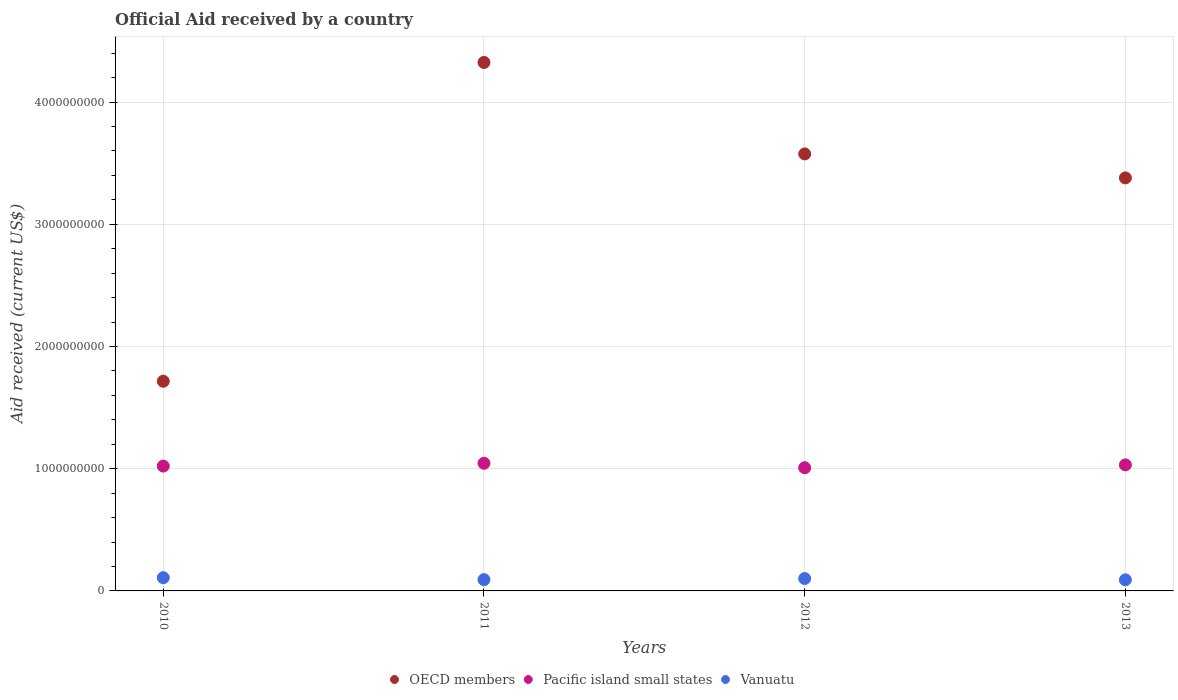What is the net official aid received in Pacific island small states in 2011?
Provide a succinct answer. 1.04e+09. Across all years, what is the maximum net official aid received in Vanuatu?
Your answer should be compact. 1.08e+08. Across all years, what is the minimum net official aid received in Pacific island small states?
Provide a succinct answer. 1.01e+09. What is the total net official aid received in OECD members in the graph?
Give a very brief answer. 1.30e+1. What is the difference between the net official aid received in Vanuatu in 2010 and that in 2013?
Make the answer very short. 1.77e+07. What is the difference between the net official aid received in Vanuatu in 2010 and the net official aid received in Pacific island small states in 2012?
Ensure brevity in your answer.  -9.00e+08. What is the average net official aid received in Vanuatu per year?
Ensure brevity in your answer.  9.81e+07. In the year 2012, what is the difference between the net official aid received in Pacific island small states and net official aid received in Vanuatu?
Keep it short and to the point. 9.06e+08. In how many years, is the net official aid received in OECD members greater than 3200000000 US$?
Ensure brevity in your answer.  3. What is the ratio of the net official aid received in Pacific island small states in 2012 to that in 2013?
Offer a very short reply. 0.98. What is the difference between the highest and the second highest net official aid received in Pacific island small states?
Provide a short and direct response. 1.30e+07. What is the difference between the highest and the lowest net official aid received in Vanuatu?
Make the answer very short. 1.77e+07. Is it the case that in every year, the sum of the net official aid received in Vanuatu and net official aid received in OECD members  is greater than the net official aid received in Pacific island small states?
Your answer should be compact. Yes. Does the net official aid received in Pacific island small states monotonically increase over the years?
Offer a very short reply. No. Is the net official aid received in OECD members strictly less than the net official aid received in Vanuatu over the years?
Provide a short and direct response. No. How many years are there in the graph?
Offer a very short reply. 4. What is the difference between two consecutive major ticks on the Y-axis?
Provide a short and direct response. 1.00e+09. Are the values on the major ticks of Y-axis written in scientific E-notation?
Keep it short and to the point. No. Does the graph contain grids?
Make the answer very short. Yes. Where does the legend appear in the graph?
Your response must be concise. Bottom center. What is the title of the graph?
Ensure brevity in your answer.  Official Aid received by a country. Does "Sub-Saharan Africa (developing only)" appear as one of the legend labels in the graph?
Make the answer very short. No. What is the label or title of the Y-axis?
Keep it short and to the point. Aid received (current US$). What is the Aid received (current US$) of OECD members in 2010?
Offer a terse response. 1.72e+09. What is the Aid received (current US$) of Pacific island small states in 2010?
Provide a short and direct response. 1.02e+09. What is the Aid received (current US$) in Vanuatu in 2010?
Your response must be concise. 1.08e+08. What is the Aid received (current US$) in OECD members in 2011?
Offer a terse response. 4.32e+09. What is the Aid received (current US$) in Pacific island small states in 2011?
Offer a very short reply. 1.04e+09. What is the Aid received (current US$) in Vanuatu in 2011?
Keep it short and to the point. 9.22e+07. What is the Aid received (current US$) in OECD members in 2012?
Make the answer very short. 3.58e+09. What is the Aid received (current US$) of Pacific island small states in 2012?
Offer a terse response. 1.01e+09. What is the Aid received (current US$) in Vanuatu in 2012?
Offer a terse response. 1.01e+08. What is the Aid received (current US$) of OECD members in 2013?
Your answer should be very brief. 3.38e+09. What is the Aid received (current US$) in Pacific island small states in 2013?
Your answer should be very brief. 1.03e+09. What is the Aid received (current US$) of Vanuatu in 2013?
Your answer should be compact. 9.06e+07. Across all years, what is the maximum Aid received (current US$) of OECD members?
Your answer should be very brief. 4.32e+09. Across all years, what is the maximum Aid received (current US$) of Pacific island small states?
Provide a succinct answer. 1.04e+09. Across all years, what is the maximum Aid received (current US$) in Vanuatu?
Your answer should be very brief. 1.08e+08. Across all years, what is the minimum Aid received (current US$) of OECD members?
Offer a very short reply. 1.72e+09. Across all years, what is the minimum Aid received (current US$) in Pacific island small states?
Your response must be concise. 1.01e+09. Across all years, what is the minimum Aid received (current US$) of Vanuatu?
Make the answer very short. 9.06e+07. What is the total Aid received (current US$) in OECD members in the graph?
Your answer should be compact. 1.30e+1. What is the total Aid received (current US$) of Pacific island small states in the graph?
Your answer should be very brief. 4.11e+09. What is the total Aid received (current US$) in Vanuatu in the graph?
Your response must be concise. 3.92e+08. What is the difference between the Aid received (current US$) in OECD members in 2010 and that in 2011?
Give a very brief answer. -2.61e+09. What is the difference between the Aid received (current US$) in Pacific island small states in 2010 and that in 2011?
Ensure brevity in your answer.  -2.31e+07. What is the difference between the Aid received (current US$) in Vanuatu in 2010 and that in 2011?
Offer a very short reply. 1.62e+07. What is the difference between the Aid received (current US$) in OECD members in 2010 and that in 2012?
Your response must be concise. -1.86e+09. What is the difference between the Aid received (current US$) of Pacific island small states in 2010 and that in 2012?
Your response must be concise. 1.36e+07. What is the difference between the Aid received (current US$) in Vanuatu in 2010 and that in 2012?
Provide a succinct answer. 6.89e+06. What is the difference between the Aid received (current US$) in OECD members in 2010 and that in 2013?
Provide a succinct answer. -1.66e+09. What is the difference between the Aid received (current US$) in Pacific island small states in 2010 and that in 2013?
Your answer should be very brief. -1.00e+07. What is the difference between the Aid received (current US$) in Vanuatu in 2010 and that in 2013?
Offer a terse response. 1.77e+07. What is the difference between the Aid received (current US$) in OECD members in 2011 and that in 2012?
Your answer should be very brief. 7.48e+08. What is the difference between the Aid received (current US$) of Pacific island small states in 2011 and that in 2012?
Ensure brevity in your answer.  3.66e+07. What is the difference between the Aid received (current US$) of Vanuatu in 2011 and that in 2012?
Your answer should be compact. -9.27e+06. What is the difference between the Aid received (current US$) of OECD members in 2011 and that in 2013?
Keep it short and to the point. 9.45e+08. What is the difference between the Aid received (current US$) in Pacific island small states in 2011 and that in 2013?
Your answer should be very brief. 1.30e+07. What is the difference between the Aid received (current US$) in Vanuatu in 2011 and that in 2013?
Make the answer very short. 1.56e+06. What is the difference between the Aid received (current US$) in OECD members in 2012 and that in 2013?
Your answer should be very brief. 1.96e+08. What is the difference between the Aid received (current US$) in Pacific island small states in 2012 and that in 2013?
Provide a short and direct response. -2.36e+07. What is the difference between the Aid received (current US$) in Vanuatu in 2012 and that in 2013?
Keep it short and to the point. 1.08e+07. What is the difference between the Aid received (current US$) in OECD members in 2010 and the Aid received (current US$) in Pacific island small states in 2011?
Provide a short and direct response. 6.71e+08. What is the difference between the Aid received (current US$) in OECD members in 2010 and the Aid received (current US$) in Vanuatu in 2011?
Your response must be concise. 1.62e+09. What is the difference between the Aid received (current US$) in Pacific island small states in 2010 and the Aid received (current US$) in Vanuatu in 2011?
Keep it short and to the point. 9.29e+08. What is the difference between the Aid received (current US$) in OECD members in 2010 and the Aid received (current US$) in Pacific island small states in 2012?
Make the answer very short. 7.08e+08. What is the difference between the Aid received (current US$) of OECD members in 2010 and the Aid received (current US$) of Vanuatu in 2012?
Provide a succinct answer. 1.61e+09. What is the difference between the Aid received (current US$) of Pacific island small states in 2010 and the Aid received (current US$) of Vanuatu in 2012?
Offer a very short reply. 9.20e+08. What is the difference between the Aid received (current US$) in OECD members in 2010 and the Aid received (current US$) in Pacific island small states in 2013?
Provide a succinct answer. 6.84e+08. What is the difference between the Aid received (current US$) of OECD members in 2010 and the Aid received (current US$) of Vanuatu in 2013?
Your answer should be very brief. 1.63e+09. What is the difference between the Aid received (current US$) of Pacific island small states in 2010 and the Aid received (current US$) of Vanuatu in 2013?
Your answer should be compact. 9.31e+08. What is the difference between the Aid received (current US$) of OECD members in 2011 and the Aid received (current US$) of Pacific island small states in 2012?
Your answer should be compact. 3.32e+09. What is the difference between the Aid received (current US$) of OECD members in 2011 and the Aid received (current US$) of Vanuatu in 2012?
Your answer should be very brief. 4.22e+09. What is the difference between the Aid received (current US$) in Pacific island small states in 2011 and the Aid received (current US$) in Vanuatu in 2012?
Your answer should be very brief. 9.43e+08. What is the difference between the Aid received (current US$) in OECD members in 2011 and the Aid received (current US$) in Pacific island small states in 2013?
Offer a terse response. 3.29e+09. What is the difference between the Aid received (current US$) in OECD members in 2011 and the Aid received (current US$) in Vanuatu in 2013?
Provide a short and direct response. 4.23e+09. What is the difference between the Aid received (current US$) in Pacific island small states in 2011 and the Aid received (current US$) in Vanuatu in 2013?
Ensure brevity in your answer.  9.54e+08. What is the difference between the Aid received (current US$) in OECD members in 2012 and the Aid received (current US$) in Pacific island small states in 2013?
Give a very brief answer. 2.54e+09. What is the difference between the Aid received (current US$) of OECD members in 2012 and the Aid received (current US$) of Vanuatu in 2013?
Give a very brief answer. 3.49e+09. What is the difference between the Aid received (current US$) of Pacific island small states in 2012 and the Aid received (current US$) of Vanuatu in 2013?
Make the answer very short. 9.17e+08. What is the average Aid received (current US$) of OECD members per year?
Offer a terse response. 3.25e+09. What is the average Aid received (current US$) of Pacific island small states per year?
Keep it short and to the point. 1.03e+09. What is the average Aid received (current US$) in Vanuatu per year?
Make the answer very short. 9.81e+07. In the year 2010, what is the difference between the Aid received (current US$) in OECD members and Aid received (current US$) in Pacific island small states?
Offer a terse response. 6.94e+08. In the year 2010, what is the difference between the Aid received (current US$) of OECD members and Aid received (current US$) of Vanuatu?
Ensure brevity in your answer.  1.61e+09. In the year 2010, what is the difference between the Aid received (current US$) of Pacific island small states and Aid received (current US$) of Vanuatu?
Keep it short and to the point. 9.13e+08. In the year 2011, what is the difference between the Aid received (current US$) of OECD members and Aid received (current US$) of Pacific island small states?
Your answer should be compact. 3.28e+09. In the year 2011, what is the difference between the Aid received (current US$) of OECD members and Aid received (current US$) of Vanuatu?
Offer a very short reply. 4.23e+09. In the year 2011, what is the difference between the Aid received (current US$) of Pacific island small states and Aid received (current US$) of Vanuatu?
Offer a very short reply. 9.52e+08. In the year 2012, what is the difference between the Aid received (current US$) in OECD members and Aid received (current US$) in Pacific island small states?
Keep it short and to the point. 2.57e+09. In the year 2012, what is the difference between the Aid received (current US$) in OECD members and Aid received (current US$) in Vanuatu?
Give a very brief answer. 3.47e+09. In the year 2012, what is the difference between the Aid received (current US$) of Pacific island small states and Aid received (current US$) of Vanuatu?
Your answer should be compact. 9.06e+08. In the year 2013, what is the difference between the Aid received (current US$) in OECD members and Aid received (current US$) in Pacific island small states?
Offer a terse response. 2.35e+09. In the year 2013, what is the difference between the Aid received (current US$) of OECD members and Aid received (current US$) of Vanuatu?
Your answer should be very brief. 3.29e+09. In the year 2013, what is the difference between the Aid received (current US$) of Pacific island small states and Aid received (current US$) of Vanuatu?
Keep it short and to the point. 9.41e+08. What is the ratio of the Aid received (current US$) in OECD members in 2010 to that in 2011?
Give a very brief answer. 0.4. What is the ratio of the Aid received (current US$) of Pacific island small states in 2010 to that in 2011?
Keep it short and to the point. 0.98. What is the ratio of the Aid received (current US$) of Vanuatu in 2010 to that in 2011?
Provide a succinct answer. 1.18. What is the ratio of the Aid received (current US$) of OECD members in 2010 to that in 2012?
Your response must be concise. 0.48. What is the ratio of the Aid received (current US$) of Pacific island small states in 2010 to that in 2012?
Your response must be concise. 1.01. What is the ratio of the Aid received (current US$) of Vanuatu in 2010 to that in 2012?
Your answer should be very brief. 1.07. What is the ratio of the Aid received (current US$) of OECD members in 2010 to that in 2013?
Make the answer very short. 0.51. What is the ratio of the Aid received (current US$) of Pacific island small states in 2010 to that in 2013?
Your answer should be compact. 0.99. What is the ratio of the Aid received (current US$) of Vanuatu in 2010 to that in 2013?
Your response must be concise. 1.2. What is the ratio of the Aid received (current US$) in OECD members in 2011 to that in 2012?
Your answer should be very brief. 1.21. What is the ratio of the Aid received (current US$) of Pacific island small states in 2011 to that in 2012?
Offer a very short reply. 1.04. What is the ratio of the Aid received (current US$) of Vanuatu in 2011 to that in 2012?
Make the answer very short. 0.91. What is the ratio of the Aid received (current US$) in OECD members in 2011 to that in 2013?
Your answer should be compact. 1.28. What is the ratio of the Aid received (current US$) of Pacific island small states in 2011 to that in 2013?
Offer a terse response. 1.01. What is the ratio of the Aid received (current US$) in Vanuatu in 2011 to that in 2013?
Your answer should be very brief. 1.02. What is the ratio of the Aid received (current US$) in OECD members in 2012 to that in 2013?
Provide a short and direct response. 1.06. What is the ratio of the Aid received (current US$) of Pacific island small states in 2012 to that in 2013?
Make the answer very short. 0.98. What is the ratio of the Aid received (current US$) of Vanuatu in 2012 to that in 2013?
Provide a succinct answer. 1.12. What is the difference between the highest and the second highest Aid received (current US$) in OECD members?
Your answer should be compact. 7.48e+08. What is the difference between the highest and the second highest Aid received (current US$) of Pacific island small states?
Offer a very short reply. 1.30e+07. What is the difference between the highest and the second highest Aid received (current US$) of Vanuatu?
Your response must be concise. 6.89e+06. What is the difference between the highest and the lowest Aid received (current US$) in OECD members?
Provide a succinct answer. 2.61e+09. What is the difference between the highest and the lowest Aid received (current US$) of Pacific island small states?
Your answer should be compact. 3.66e+07. What is the difference between the highest and the lowest Aid received (current US$) in Vanuatu?
Provide a short and direct response. 1.77e+07. 